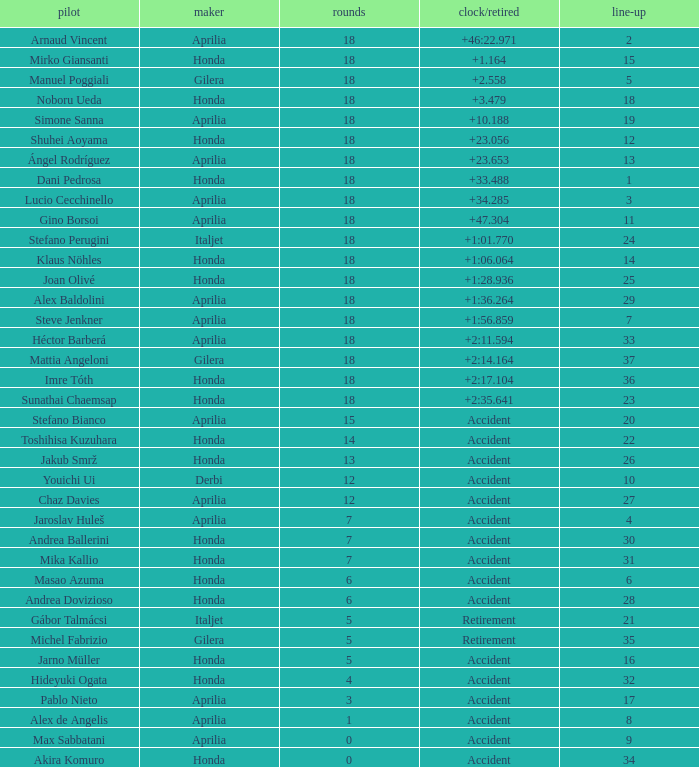Who is the rider with less than 15 laps, more than 32 grids, and an accident time/retired? Akira Komuro. 